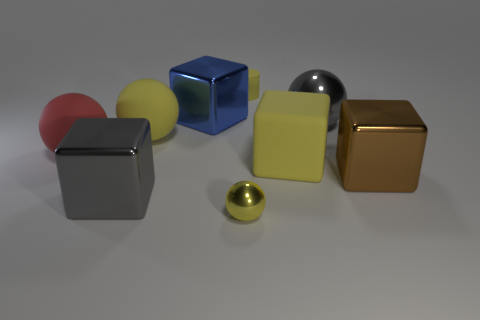There is a thing that is the same color as the big shiny ball; what is its shape? The object that shares the same color as the big shiny ball is a cube. It's equally fascinating to see how geometry and hues can interact in a scene to create visual coherence. 